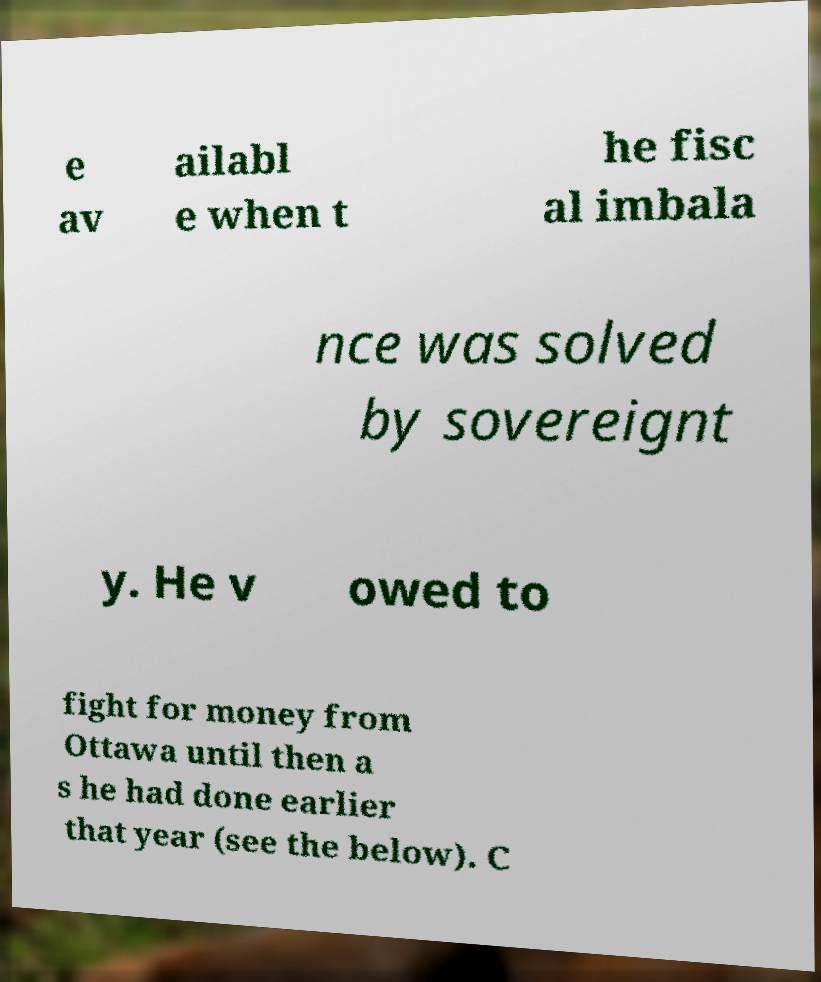I need the written content from this picture converted into text. Can you do that? e av ailabl e when t he fisc al imbala nce was solved by sovereignt y. He v owed to fight for money from Ottawa until then a s he had done earlier that year (see the below). C 